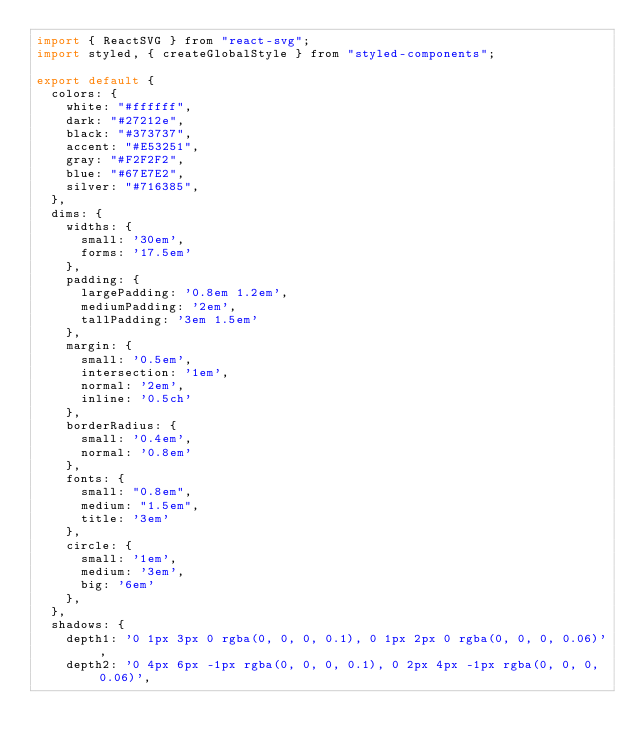<code> <loc_0><loc_0><loc_500><loc_500><_JavaScript_>import { ReactSVG } from "react-svg";
import styled, { createGlobalStyle } from "styled-components";

export default {
  colors: {
    white: "#ffffff",
    dark: "#27212e",
    black: "#373737",
    accent: "#E53251",
    gray: "#F2F2F2",
    blue: "#67E7E2",
    silver: "#716385",
  },
  dims: {
    widths: {
      small: '30em',
      forms: '17.5em'
    },
    padding: {
      largePadding: '0.8em 1.2em',
      mediumPadding: '2em',
      tallPadding: '3em 1.5em'
    },
    margin: {
      small: '0.5em',
      intersection: '1em',
      normal: '2em',
      inline: '0.5ch'
    },
    borderRadius: {
      small: '0.4em',
      normal: '0.8em'
    },
    fonts: {
      small: "0.8em",
      medium: "1.5em",
      title: '3em'
    },
    circle: {
      small: '1em',
      medium: '3em',
      big: '6em'
    },
  },
  shadows: {
    depth1: '0 1px 3px 0 rgba(0, 0, 0, 0.1), 0 1px 2px 0 rgba(0, 0, 0, 0.06)',
    depth2: '0 4px 6px -1px rgba(0, 0, 0, 0.1), 0 2px 4px -1px rgba(0, 0, 0, 0.06)',</code> 